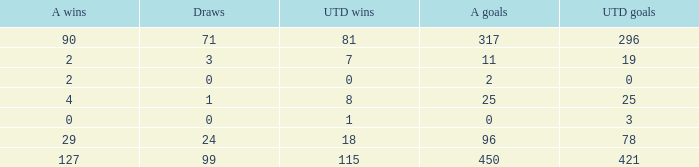What is the sum of Alianza Wins, when Alianza Goals is "317, and when U Goals is greater than 296? None. 